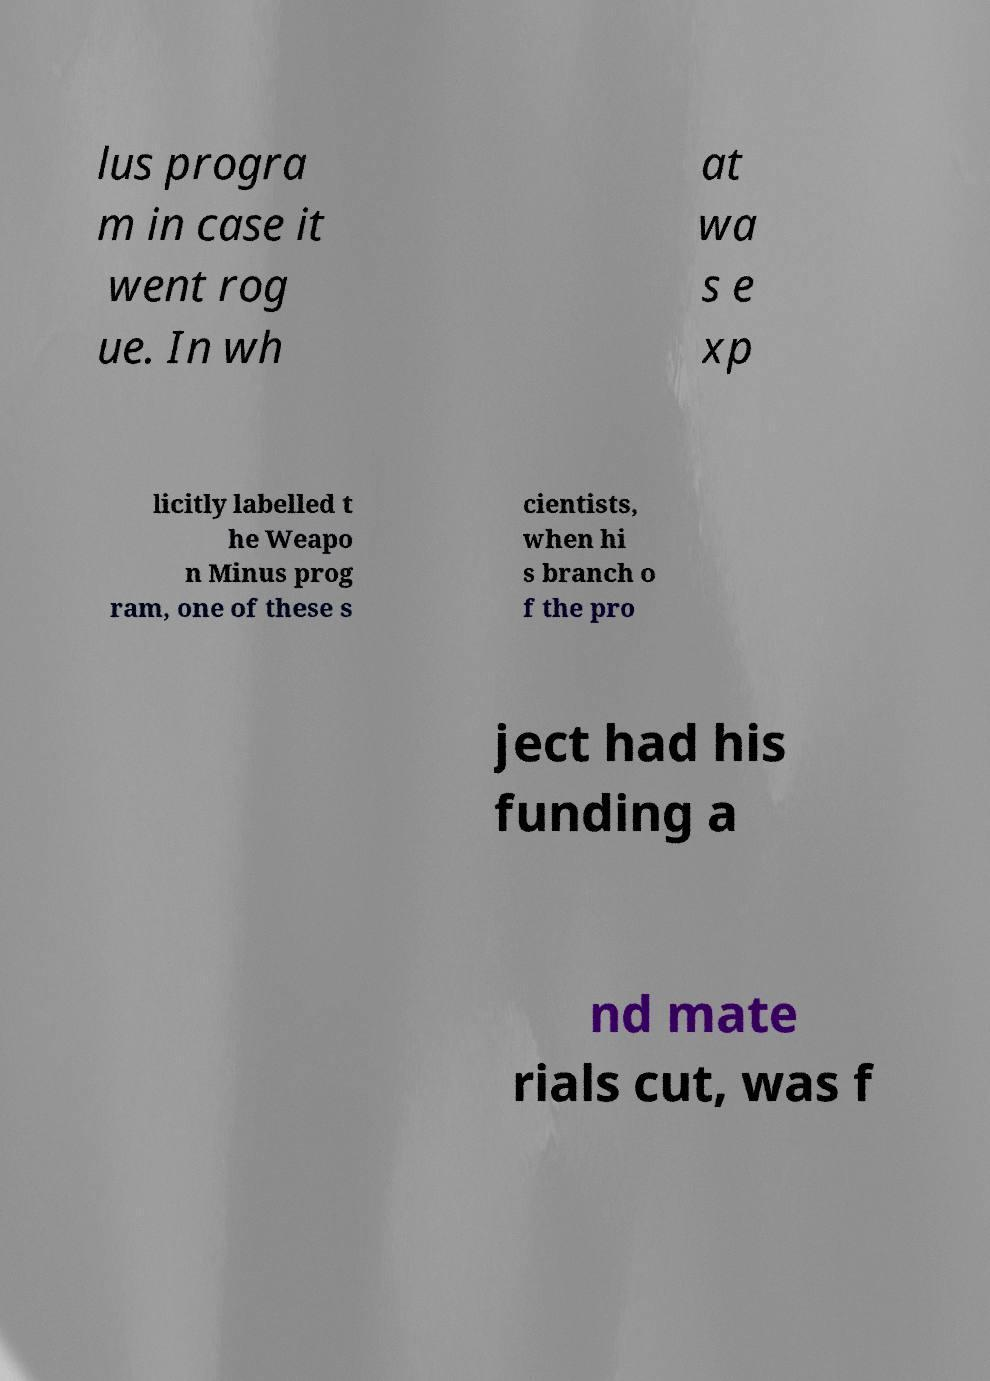I need the written content from this picture converted into text. Can you do that? lus progra m in case it went rog ue. In wh at wa s e xp licitly labelled t he Weapo n Minus prog ram, one of these s cientists, when hi s branch o f the pro ject had his funding a nd mate rials cut, was f 